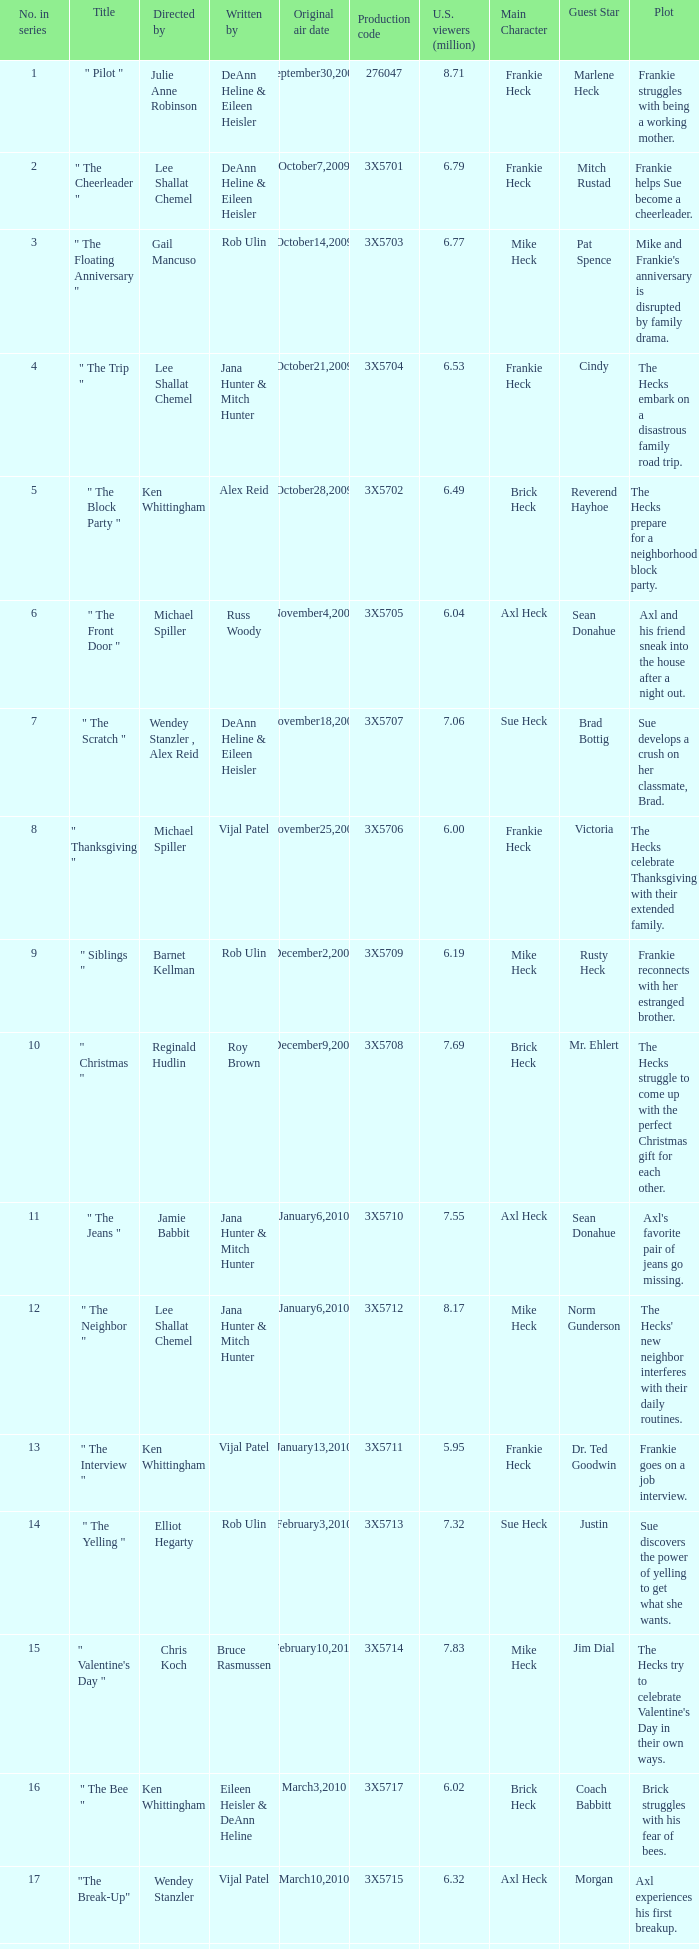Which episode holds the title that alex reid directed? "The Final Four". 